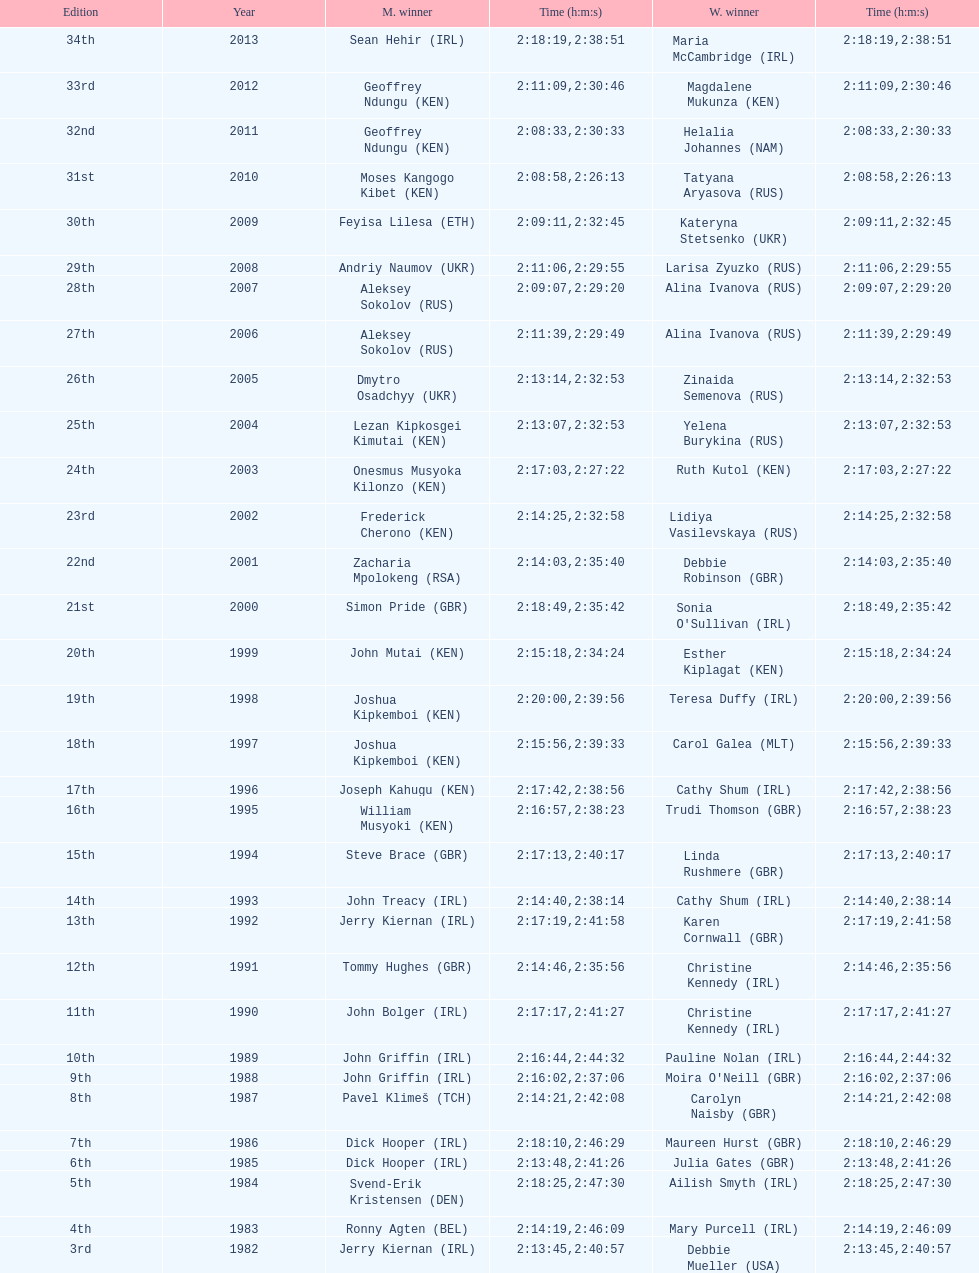Who had the longest duration among all the runners? Maria McCambridge (IRL). 